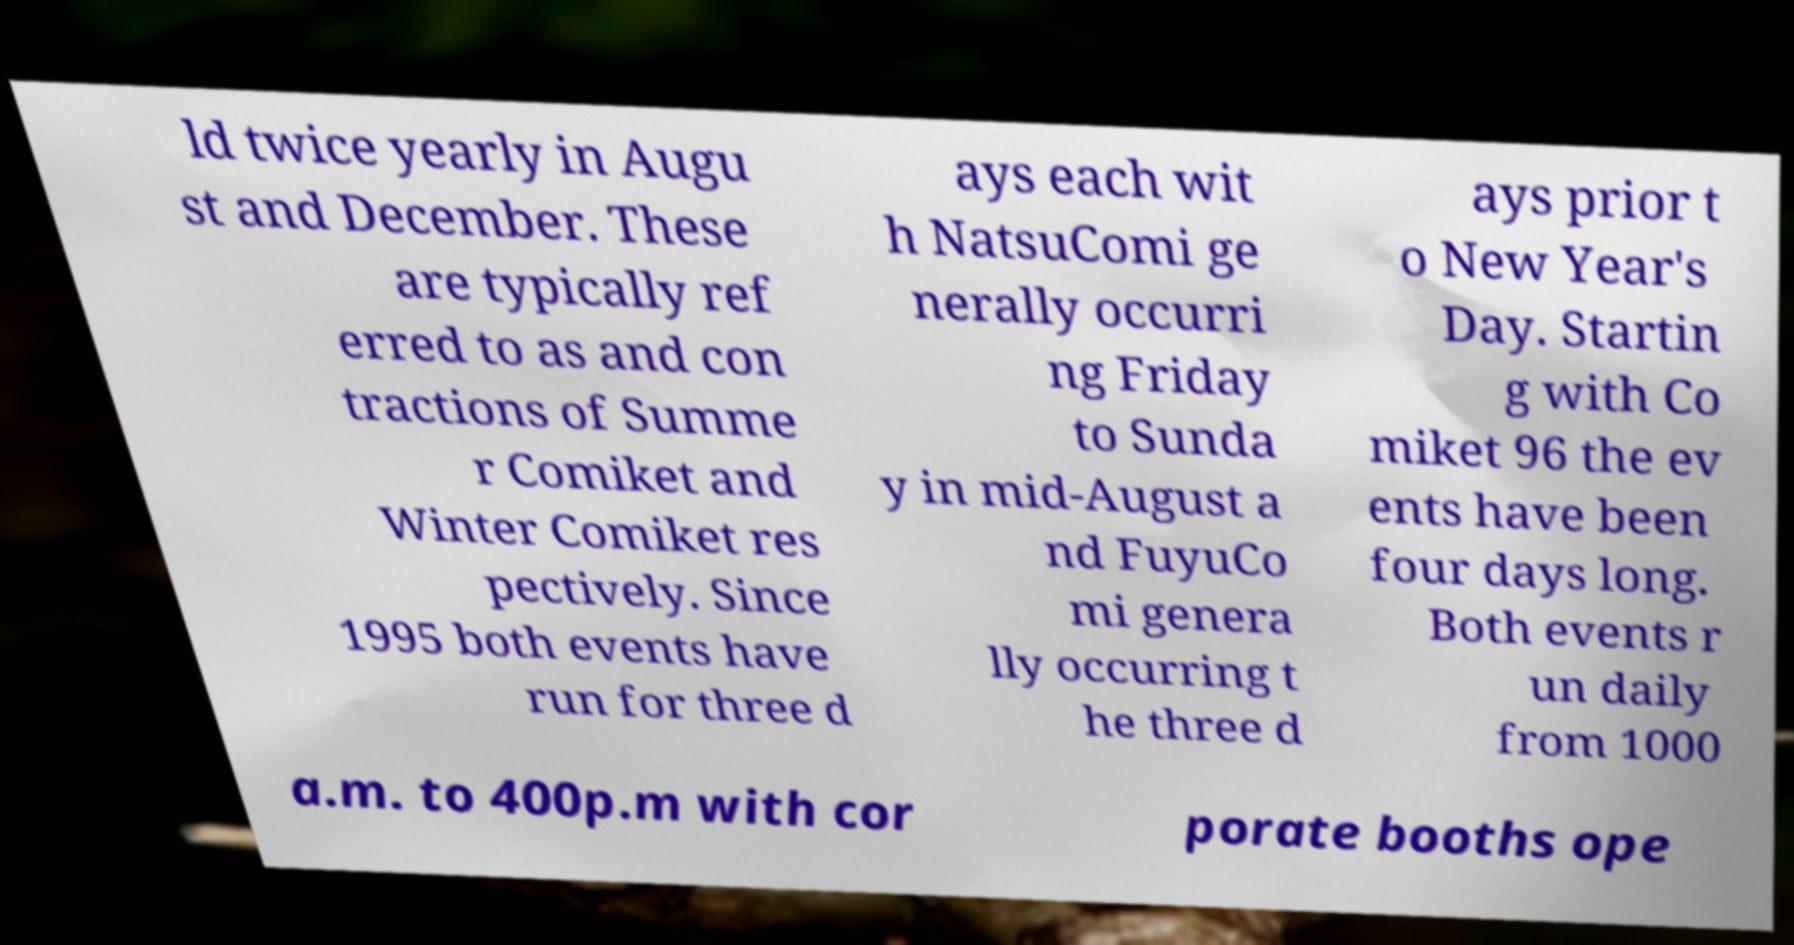For documentation purposes, I need the text within this image transcribed. Could you provide that? ld twice yearly in Augu st and December. These are typically ref erred to as and con tractions of Summe r Comiket and Winter Comiket res pectively. Since 1995 both events have run for three d ays each wit h NatsuComi ge nerally occurri ng Friday to Sunda y in mid-August a nd FuyuCo mi genera lly occurring t he three d ays prior t o New Year's Day. Startin g with Co miket 96 the ev ents have been four days long. Both events r un daily from 1000 a.m. to 400p.m with cor porate booths ope 